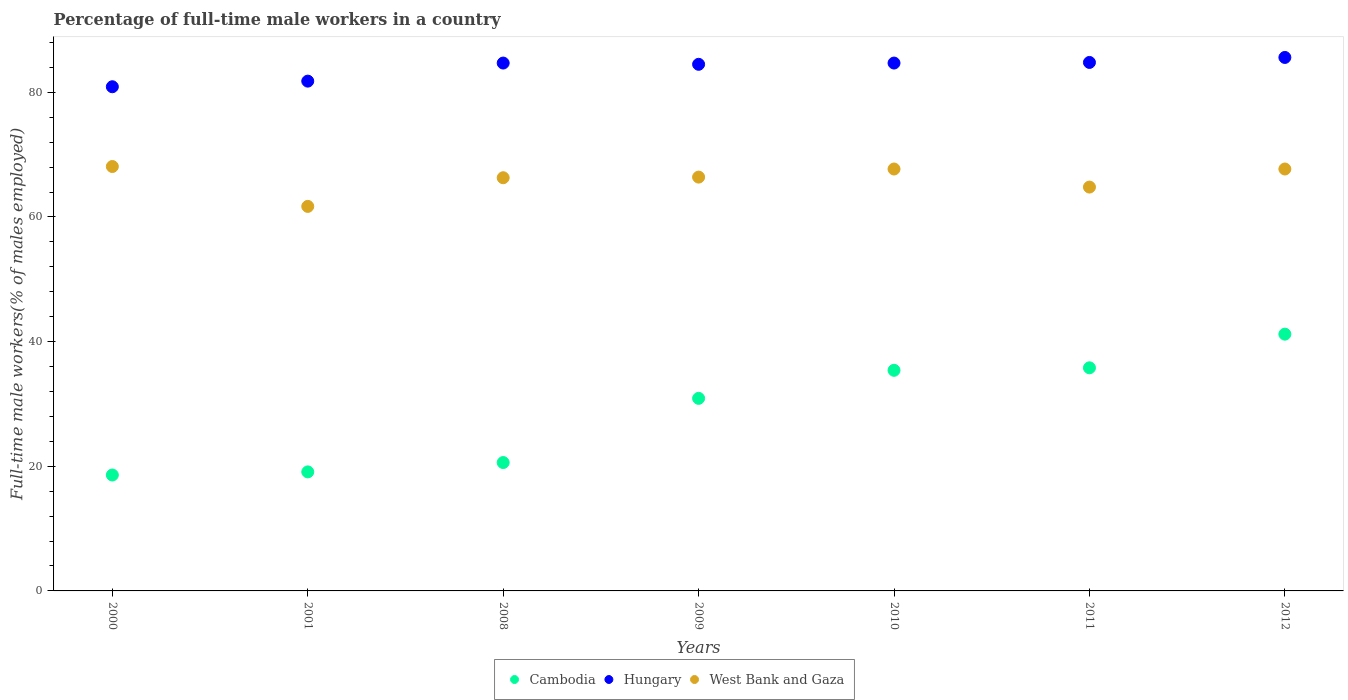Is the number of dotlines equal to the number of legend labels?
Offer a terse response. Yes. What is the percentage of full-time male workers in West Bank and Gaza in 2008?
Provide a succinct answer. 66.3. Across all years, what is the maximum percentage of full-time male workers in Hungary?
Make the answer very short. 85.6. Across all years, what is the minimum percentage of full-time male workers in West Bank and Gaza?
Ensure brevity in your answer.  61.7. In which year was the percentage of full-time male workers in West Bank and Gaza maximum?
Make the answer very short. 2000. What is the total percentage of full-time male workers in Cambodia in the graph?
Your response must be concise. 201.6. What is the difference between the percentage of full-time male workers in West Bank and Gaza in 2008 and that in 2010?
Provide a short and direct response. -1.4. What is the difference between the percentage of full-time male workers in West Bank and Gaza in 2000 and the percentage of full-time male workers in Cambodia in 2010?
Your response must be concise. 32.7. What is the average percentage of full-time male workers in Cambodia per year?
Give a very brief answer. 28.8. In the year 2000, what is the difference between the percentage of full-time male workers in Cambodia and percentage of full-time male workers in Hungary?
Your answer should be very brief. -62.3. What is the ratio of the percentage of full-time male workers in Hungary in 2001 to that in 2008?
Offer a very short reply. 0.97. Is the difference between the percentage of full-time male workers in Cambodia in 2000 and 2008 greater than the difference between the percentage of full-time male workers in Hungary in 2000 and 2008?
Offer a terse response. Yes. What is the difference between the highest and the second highest percentage of full-time male workers in West Bank and Gaza?
Your answer should be very brief. 0.4. What is the difference between the highest and the lowest percentage of full-time male workers in Cambodia?
Offer a very short reply. 22.6. Is it the case that in every year, the sum of the percentage of full-time male workers in Cambodia and percentage of full-time male workers in West Bank and Gaza  is greater than the percentage of full-time male workers in Hungary?
Provide a short and direct response. No. Does the percentage of full-time male workers in Cambodia monotonically increase over the years?
Provide a succinct answer. Yes. Is the percentage of full-time male workers in West Bank and Gaza strictly less than the percentage of full-time male workers in Cambodia over the years?
Offer a very short reply. No. Are the values on the major ticks of Y-axis written in scientific E-notation?
Provide a succinct answer. No. How are the legend labels stacked?
Give a very brief answer. Horizontal. What is the title of the graph?
Offer a very short reply. Percentage of full-time male workers in a country. What is the label or title of the X-axis?
Keep it short and to the point. Years. What is the label or title of the Y-axis?
Give a very brief answer. Full-time male workers(% of males employed). What is the Full-time male workers(% of males employed) of Cambodia in 2000?
Give a very brief answer. 18.6. What is the Full-time male workers(% of males employed) in Hungary in 2000?
Give a very brief answer. 80.9. What is the Full-time male workers(% of males employed) of West Bank and Gaza in 2000?
Your answer should be very brief. 68.1. What is the Full-time male workers(% of males employed) in Cambodia in 2001?
Give a very brief answer. 19.1. What is the Full-time male workers(% of males employed) of Hungary in 2001?
Provide a succinct answer. 81.8. What is the Full-time male workers(% of males employed) of West Bank and Gaza in 2001?
Make the answer very short. 61.7. What is the Full-time male workers(% of males employed) of Cambodia in 2008?
Ensure brevity in your answer.  20.6. What is the Full-time male workers(% of males employed) of Hungary in 2008?
Your answer should be very brief. 84.7. What is the Full-time male workers(% of males employed) in West Bank and Gaza in 2008?
Offer a terse response. 66.3. What is the Full-time male workers(% of males employed) in Cambodia in 2009?
Make the answer very short. 30.9. What is the Full-time male workers(% of males employed) of Hungary in 2009?
Keep it short and to the point. 84.5. What is the Full-time male workers(% of males employed) of West Bank and Gaza in 2009?
Give a very brief answer. 66.4. What is the Full-time male workers(% of males employed) in Cambodia in 2010?
Your answer should be very brief. 35.4. What is the Full-time male workers(% of males employed) of Hungary in 2010?
Keep it short and to the point. 84.7. What is the Full-time male workers(% of males employed) in West Bank and Gaza in 2010?
Your answer should be compact. 67.7. What is the Full-time male workers(% of males employed) in Cambodia in 2011?
Your response must be concise. 35.8. What is the Full-time male workers(% of males employed) of Hungary in 2011?
Provide a succinct answer. 84.8. What is the Full-time male workers(% of males employed) of West Bank and Gaza in 2011?
Your answer should be very brief. 64.8. What is the Full-time male workers(% of males employed) in Cambodia in 2012?
Ensure brevity in your answer.  41.2. What is the Full-time male workers(% of males employed) in Hungary in 2012?
Keep it short and to the point. 85.6. What is the Full-time male workers(% of males employed) of West Bank and Gaza in 2012?
Provide a succinct answer. 67.7. Across all years, what is the maximum Full-time male workers(% of males employed) of Cambodia?
Ensure brevity in your answer.  41.2. Across all years, what is the maximum Full-time male workers(% of males employed) in Hungary?
Ensure brevity in your answer.  85.6. Across all years, what is the maximum Full-time male workers(% of males employed) in West Bank and Gaza?
Offer a terse response. 68.1. Across all years, what is the minimum Full-time male workers(% of males employed) in Cambodia?
Make the answer very short. 18.6. Across all years, what is the minimum Full-time male workers(% of males employed) of Hungary?
Your response must be concise. 80.9. Across all years, what is the minimum Full-time male workers(% of males employed) of West Bank and Gaza?
Provide a short and direct response. 61.7. What is the total Full-time male workers(% of males employed) of Cambodia in the graph?
Provide a succinct answer. 201.6. What is the total Full-time male workers(% of males employed) in Hungary in the graph?
Make the answer very short. 587. What is the total Full-time male workers(% of males employed) in West Bank and Gaza in the graph?
Your answer should be compact. 462.7. What is the difference between the Full-time male workers(% of males employed) in Hungary in 2000 and that in 2001?
Provide a short and direct response. -0.9. What is the difference between the Full-time male workers(% of males employed) in Cambodia in 2000 and that in 2008?
Your answer should be compact. -2. What is the difference between the Full-time male workers(% of males employed) of Hungary in 2000 and that in 2008?
Make the answer very short. -3.8. What is the difference between the Full-time male workers(% of males employed) of West Bank and Gaza in 2000 and that in 2009?
Make the answer very short. 1.7. What is the difference between the Full-time male workers(% of males employed) of Cambodia in 2000 and that in 2010?
Make the answer very short. -16.8. What is the difference between the Full-time male workers(% of males employed) of Hungary in 2000 and that in 2010?
Give a very brief answer. -3.8. What is the difference between the Full-time male workers(% of males employed) in West Bank and Gaza in 2000 and that in 2010?
Ensure brevity in your answer.  0.4. What is the difference between the Full-time male workers(% of males employed) of Cambodia in 2000 and that in 2011?
Make the answer very short. -17.2. What is the difference between the Full-time male workers(% of males employed) of Hungary in 2000 and that in 2011?
Ensure brevity in your answer.  -3.9. What is the difference between the Full-time male workers(% of males employed) of Cambodia in 2000 and that in 2012?
Your response must be concise. -22.6. What is the difference between the Full-time male workers(% of males employed) of Hungary in 2000 and that in 2012?
Offer a very short reply. -4.7. What is the difference between the Full-time male workers(% of males employed) of Cambodia in 2001 and that in 2008?
Offer a terse response. -1.5. What is the difference between the Full-time male workers(% of males employed) of Hungary in 2001 and that in 2009?
Your response must be concise. -2.7. What is the difference between the Full-time male workers(% of males employed) in West Bank and Gaza in 2001 and that in 2009?
Your response must be concise. -4.7. What is the difference between the Full-time male workers(% of males employed) of Cambodia in 2001 and that in 2010?
Your answer should be compact. -16.3. What is the difference between the Full-time male workers(% of males employed) of West Bank and Gaza in 2001 and that in 2010?
Keep it short and to the point. -6. What is the difference between the Full-time male workers(% of males employed) in Cambodia in 2001 and that in 2011?
Offer a terse response. -16.7. What is the difference between the Full-time male workers(% of males employed) in Hungary in 2001 and that in 2011?
Give a very brief answer. -3. What is the difference between the Full-time male workers(% of males employed) in West Bank and Gaza in 2001 and that in 2011?
Keep it short and to the point. -3.1. What is the difference between the Full-time male workers(% of males employed) of Cambodia in 2001 and that in 2012?
Provide a succinct answer. -22.1. What is the difference between the Full-time male workers(% of males employed) of Cambodia in 2008 and that in 2010?
Give a very brief answer. -14.8. What is the difference between the Full-time male workers(% of males employed) of Hungary in 2008 and that in 2010?
Your response must be concise. 0. What is the difference between the Full-time male workers(% of males employed) in West Bank and Gaza in 2008 and that in 2010?
Keep it short and to the point. -1.4. What is the difference between the Full-time male workers(% of males employed) in Cambodia in 2008 and that in 2011?
Your answer should be compact. -15.2. What is the difference between the Full-time male workers(% of males employed) in Hungary in 2008 and that in 2011?
Offer a terse response. -0.1. What is the difference between the Full-time male workers(% of males employed) of Cambodia in 2008 and that in 2012?
Make the answer very short. -20.6. What is the difference between the Full-time male workers(% of males employed) in Hungary in 2008 and that in 2012?
Offer a terse response. -0.9. What is the difference between the Full-time male workers(% of males employed) of Cambodia in 2009 and that in 2010?
Give a very brief answer. -4.5. What is the difference between the Full-time male workers(% of males employed) in Hungary in 2009 and that in 2010?
Provide a succinct answer. -0.2. What is the difference between the Full-time male workers(% of males employed) of Hungary in 2009 and that in 2011?
Keep it short and to the point. -0.3. What is the difference between the Full-time male workers(% of males employed) of West Bank and Gaza in 2009 and that in 2011?
Give a very brief answer. 1.6. What is the difference between the Full-time male workers(% of males employed) in Cambodia in 2009 and that in 2012?
Offer a very short reply. -10.3. What is the difference between the Full-time male workers(% of males employed) of West Bank and Gaza in 2009 and that in 2012?
Your answer should be compact. -1.3. What is the difference between the Full-time male workers(% of males employed) in Cambodia in 2010 and that in 2011?
Your response must be concise. -0.4. What is the difference between the Full-time male workers(% of males employed) in Cambodia in 2011 and that in 2012?
Ensure brevity in your answer.  -5.4. What is the difference between the Full-time male workers(% of males employed) of Hungary in 2011 and that in 2012?
Ensure brevity in your answer.  -0.8. What is the difference between the Full-time male workers(% of males employed) in Cambodia in 2000 and the Full-time male workers(% of males employed) in Hungary in 2001?
Give a very brief answer. -63.2. What is the difference between the Full-time male workers(% of males employed) in Cambodia in 2000 and the Full-time male workers(% of males employed) in West Bank and Gaza in 2001?
Provide a succinct answer. -43.1. What is the difference between the Full-time male workers(% of males employed) of Hungary in 2000 and the Full-time male workers(% of males employed) of West Bank and Gaza in 2001?
Your answer should be very brief. 19.2. What is the difference between the Full-time male workers(% of males employed) of Cambodia in 2000 and the Full-time male workers(% of males employed) of Hungary in 2008?
Keep it short and to the point. -66.1. What is the difference between the Full-time male workers(% of males employed) of Cambodia in 2000 and the Full-time male workers(% of males employed) of West Bank and Gaza in 2008?
Your answer should be very brief. -47.7. What is the difference between the Full-time male workers(% of males employed) in Hungary in 2000 and the Full-time male workers(% of males employed) in West Bank and Gaza in 2008?
Offer a terse response. 14.6. What is the difference between the Full-time male workers(% of males employed) of Cambodia in 2000 and the Full-time male workers(% of males employed) of Hungary in 2009?
Provide a succinct answer. -65.9. What is the difference between the Full-time male workers(% of males employed) of Cambodia in 2000 and the Full-time male workers(% of males employed) of West Bank and Gaza in 2009?
Your answer should be compact. -47.8. What is the difference between the Full-time male workers(% of males employed) of Cambodia in 2000 and the Full-time male workers(% of males employed) of Hungary in 2010?
Make the answer very short. -66.1. What is the difference between the Full-time male workers(% of males employed) in Cambodia in 2000 and the Full-time male workers(% of males employed) in West Bank and Gaza in 2010?
Offer a very short reply. -49.1. What is the difference between the Full-time male workers(% of males employed) of Cambodia in 2000 and the Full-time male workers(% of males employed) of Hungary in 2011?
Offer a very short reply. -66.2. What is the difference between the Full-time male workers(% of males employed) of Cambodia in 2000 and the Full-time male workers(% of males employed) of West Bank and Gaza in 2011?
Give a very brief answer. -46.2. What is the difference between the Full-time male workers(% of males employed) of Cambodia in 2000 and the Full-time male workers(% of males employed) of Hungary in 2012?
Make the answer very short. -67. What is the difference between the Full-time male workers(% of males employed) of Cambodia in 2000 and the Full-time male workers(% of males employed) of West Bank and Gaza in 2012?
Ensure brevity in your answer.  -49.1. What is the difference between the Full-time male workers(% of males employed) of Cambodia in 2001 and the Full-time male workers(% of males employed) of Hungary in 2008?
Your answer should be very brief. -65.6. What is the difference between the Full-time male workers(% of males employed) in Cambodia in 2001 and the Full-time male workers(% of males employed) in West Bank and Gaza in 2008?
Ensure brevity in your answer.  -47.2. What is the difference between the Full-time male workers(% of males employed) in Hungary in 2001 and the Full-time male workers(% of males employed) in West Bank and Gaza in 2008?
Offer a terse response. 15.5. What is the difference between the Full-time male workers(% of males employed) of Cambodia in 2001 and the Full-time male workers(% of males employed) of Hungary in 2009?
Give a very brief answer. -65.4. What is the difference between the Full-time male workers(% of males employed) in Cambodia in 2001 and the Full-time male workers(% of males employed) in West Bank and Gaza in 2009?
Provide a succinct answer. -47.3. What is the difference between the Full-time male workers(% of males employed) of Cambodia in 2001 and the Full-time male workers(% of males employed) of Hungary in 2010?
Offer a terse response. -65.6. What is the difference between the Full-time male workers(% of males employed) of Cambodia in 2001 and the Full-time male workers(% of males employed) of West Bank and Gaza in 2010?
Your answer should be very brief. -48.6. What is the difference between the Full-time male workers(% of males employed) in Cambodia in 2001 and the Full-time male workers(% of males employed) in Hungary in 2011?
Your answer should be very brief. -65.7. What is the difference between the Full-time male workers(% of males employed) of Cambodia in 2001 and the Full-time male workers(% of males employed) of West Bank and Gaza in 2011?
Give a very brief answer. -45.7. What is the difference between the Full-time male workers(% of males employed) in Hungary in 2001 and the Full-time male workers(% of males employed) in West Bank and Gaza in 2011?
Provide a short and direct response. 17. What is the difference between the Full-time male workers(% of males employed) in Cambodia in 2001 and the Full-time male workers(% of males employed) in Hungary in 2012?
Make the answer very short. -66.5. What is the difference between the Full-time male workers(% of males employed) of Cambodia in 2001 and the Full-time male workers(% of males employed) of West Bank and Gaza in 2012?
Your answer should be very brief. -48.6. What is the difference between the Full-time male workers(% of males employed) in Hungary in 2001 and the Full-time male workers(% of males employed) in West Bank and Gaza in 2012?
Your answer should be very brief. 14.1. What is the difference between the Full-time male workers(% of males employed) of Cambodia in 2008 and the Full-time male workers(% of males employed) of Hungary in 2009?
Make the answer very short. -63.9. What is the difference between the Full-time male workers(% of males employed) of Cambodia in 2008 and the Full-time male workers(% of males employed) of West Bank and Gaza in 2009?
Provide a succinct answer. -45.8. What is the difference between the Full-time male workers(% of males employed) of Hungary in 2008 and the Full-time male workers(% of males employed) of West Bank and Gaza in 2009?
Keep it short and to the point. 18.3. What is the difference between the Full-time male workers(% of males employed) of Cambodia in 2008 and the Full-time male workers(% of males employed) of Hungary in 2010?
Your answer should be very brief. -64.1. What is the difference between the Full-time male workers(% of males employed) in Cambodia in 2008 and the Full-time male workers(% of males employed) in West Bank and Gaza in 2010?
Offer a terse response. -47.1. What is the difference between the Full-time male workers(% of males employed) in Cambodia in 2008 and the Full-time male workers(% of males employed) in Hungary in 2011?
Offer a very short reply. -64.2. What is the difference between the Full-time male workers(% of males employed) of Cambodia in 2008 and the Full-time male workers(% of males employed) of West Bank and Gaza in 2011?
Ensure brevity in your answer.  -44.2. What is the difference between the Full-time male workers(% of males employed) in Cambodia in 2008 and the Full-time male workers(% of males employed) in Hungary in 2012?
Keep it short and to the point. -65. What is the difference between the Full-time male workers(% of males employed) in Cambodia in 2008 and the Full-time male workers(% of males employed) in West Bank and Gaza in 2012?
Provide a short and direct response. -47.1. What is the difference between the Full-time male workers(% of males employed) of Cambodia in 2009 and the Full-time male workers(% of males employed) of Hungary in 2010?
Give a very brief answer. -53.8. What is the difference between the Full-time male workers(% of males employed) in Cambodia in 2009 and the Full-time male workers(% of males employed) in West Bank and Gaza in 2010?
Make the answer very short. -36.8. What is the difference between the Full-time male workers(% of males employed) of Cambodia in 2009 and the Full-time male workers(% of males employed) of Hungary in 2011?
Make the answer very short. -53.9. What is the difference between the Full-time male workers(% of males employed) of Cambodia in 2009 and the Full-time male workers(% of males employed) of West Bank and Gaza in 2011?
Your response must be concise. -33.9. What is the difference between the Full-time male workers(% of males employed) in Cambodia in 2009 and the Full-time male workers(% of males employed) in Hungary in 2012?
Your response must be concise. -54.7. What is the difference between the Full-time male workers(% of males employed) in Cambodia in 2009 and the Full-time male workers(% of males employed) in West Bank and Gaza in 2012?
Your answer should be very brief. -36.8. What is the difference between the Full-time male workers(% of males employed) in Hungary in 2009 and the Full-time male workers(% of males employed) in West Bank and Gaza in 2012?
Your response must be concise. 16.8. What is the difference between the Full-time male workers(% of males employed) in Cambodia in 2010 and the Full-time male workers(% of males employed) in Hungary in 2011?
Provide a succinct answer. -49.4. What is the difference between the Full-time male workers(% of males employed) of Cambodia in 2010 and the Full-time male workers(% of males employed) of West Bank and Gaza in 2011?
Provide a succinct answer. -29.4. What is the difference between the Full-time male workers(% of males employed) of Cambodia in 2010 and the Full-time male workers(% of males employed) of Hungary in 2012?
Make the answer very short. -50.2. What is the difference between the Full-time male workers(% of males employed) of Cambodia in 2010 and the Full-time male workers(% of males employed) of West Bank and Gaza in 2012?
Ensure brevity in your answer.  -32.3. What is the difference between the Full-time male workers(% of males employed) in Cambodia in 2011 and the Full-time male workers(% of males employed) in Hungary in 2012?
Give a very brief answer. -49.8. What is the difference between the Full-time male workers(% of males employed) in Cambodia in 2011 and the Full-time male workers(% of males employed) in West Bank and Gaza in 2012?
Provide a short and direct response. -31.9. What is the average Full-time male workers(% of males employed) in Cambodia per year?
Provide a short and direct response. 28.8. What is the average Full-time male workers(% of males employed) of Hungary per year?
Give a very brief answer. 83.86. What is the average Full-time male workers(% of males employed) in West Bank and Gaza per year?
Your answer should be compact. 66.1. In the year 2000, what is the difference between the Full-time male workers(% of males employed) in Cambodia and Full-time male workers(% of males employed) in Hungary?
Offer a terse response. -62.3. In the year 2000, what is the difference between the Full-time male workers(% of males employed) of Cambodia and Full-time male workers(% of males employed) of West Bank and Gaza?
Your answer should be very brief. -49.5. In the year 2000, what is the difference between the Full-time male workers(% of males employed) of Hungary and Full-time male workers(% of males employed) of West Bank and Gaza?
Provide a succinct answer. 12.8. In the year 2001, what is the difference between the Full-time male workers(% of males employed) in Cambodia and Full-time male workers(% of males employed) in Hungary?
Keep it short and to the point. -62.7. In the year 2001, what is the difference between the Full-time male workers(% of males employed) in Cambodia and Full-time male workers(% of males employed) in West Bank and Gaza?
Give a very brief answer. -42.6. In the year 2001, what is the difference between the Full-time male workers(% of males employed) in Hungary and Full-time male workers(% of males employed) in West Bank and Gaza?
Make the answer very short. 20.1. In the year 2008, what is the difference between the Full-time male workers(% of males employed) of Cambodia and Full-time male workers(% of males employed) of Hungary?
Keep it short and to the point. -64.1. In the year 2008, what is the difference between the Full-time male workers(% of males employed) in Cambodia and Full-time male workers(% of males employed) in West Bank and Gaza?
Offer a terse response. -45.7. In the year 2008, what is the difference between the Full-time male workers(% of males employed) of Hungary and Full-time male workers(% of males employed) of West Bank and Gaza?
Make the answer very short. 18.4. In the year 2009, what is the difference between the Full-time male workers(% of males employed) of Cambodia and Full-time male workers(% of males employed) of Hungary?
Provide a succinct answer. -53.6. In the year 2009, what is the difference between the Full-time male workers(% of males employed) of Cambodia and Full-time male workers(% of males employed) of West Bank and Gaza?
Provide a succinct answer. -35.5. In the year 2010, what is the difference between the Full-time male workers(% of males employed) in Cambodia and Full-time male workers(% of males employed) in Hungary?
Give a very brief answer. -49.3. In the year 2010, what is the difference between the Full-time male workers(% of males employed) of Cambodia and Full-time male workers(% of males employed) of West Bank and Gaza?
Your answer should be compact. -32.3. In the year 2011, what is the difference between the Full-time male workers(% of males employed) of Cambodia and Full-time male workers(% of males employed) of Hungary?
Make the answer very short. -49. In the year 2012, what is the difference between the Full-time male workers(% of males employed) of Cambodia and Full-time male workers(% of males employed) of Hungary?
Provide a succinct answer. -44.4. In the year 2012, what is the difference between the Full-time male workers(% of males employed) in Cambodia and Full-time male workers(% of males employed) in West Bank and Gaza?
Your response must be concise. -26.5. What is the ratio of the Full-time male workers(% of males employed) of Cambodia in 2000 to that in 2001?
Make the answer very short. 0.97. What is the ratio of the Full-time male workers(% of males employed) of Hungary in 2000 to that in 2001?
Give a very brief answer. 0.99. What is the ratio of the Full-time male workers(% of males employed) of West Bank and Gaza in 2000 to that in 2001?
Your answer should be very brief. 1.1. What is the ratio of the Full-time male workers(% of males employed) in Cambodia in 2000 to that in 2008?
Your answer should be very brief. 0.9. What is the ratio of the Full-time male workers(% of males employed) in Hungary in 2000 to that in 2008?
Provide a short and direct response. 0.96. What is the ratio of the Full-time male workers(% of males employed) in West Bank and Gaza in 2000 to that in 2008?
Provide a short and direct response. 1.03. What is the ratio of the Full-time male workers(% of males employed) in Cambodia in 2000 to that in 2009?
Give a very brief answer. 0.6. What is the ratio of the Full-time male workers(% of males employed) in Hungary in 2000 to that in 2009?
Your answer should be compact. 0.96. What is the ratio of the Full-time male workers(% of males employed) in West Bank and Gaza in 2000 to that in 2009?
Give a very brief answer. 1.03. What is the ratio of the Full-time male workers(% of males employed) in Cambodia in 2000 to that in 2010?
Give a very brief answer. 0.53. What is the ratio of the Full-time male workers(% of males employed) in Hungary in 2000 to that in 2010?
Provide a succinct answer. 0.96. What is the ratio of the Full-time male workers(% of males employed) in West Bank and Gaza in 2000 to that in 2010?
Provide a short and direct response. 1.01. What is the ratio of the Full-time male workers(% of males employed) in Cambodia in 2000 to that in 2011?
Keep it short and to the point. 0.52. What is the ratio of the Full-time male workers(% of males employed) in Hungary in 2000 to that in 2011?
Give a very brief answer. 0.95. What is the ratio of the Full-time male workers(% of males employed) of West Bank and Gaza in 2000 to that in 2011?
Offer a very short reply. 1.05. What is the ratio of the Full-time male workers(% of males employed) in Cambodia in 2000 to that in 2012?
Make the answer very short. 0.45. What is the ratio of the Full-time male workers(% of males employed) in Hungary in 2000 to that in 2012?
Offer a very short reply. 0.95. What is the ratio of the Full-time male workers(% of males employed) in West Bank and Gaza in 2000 to that in 2012?
Offer a very short reply. 1.01. What is the ratio of the Full-time male workers(% of males employed) of Cambodia in 2001 to that in 2008?
Provide a succinct answer. 0.93. What is the ratio of the Full-time male workers(% of males employed) of Hungary in 2001 to that in 2008?
Provide a succinct answer. 0.97. What is the ratio of the Full-time male workers(% of males employed) in West Bank and Gaza in 2001 to that in 2008?
Ensure brevity in your answer.  0.93. What is the ratio of the Full-time male workers(% of males employed) in Cambodia in 2001 to that in 2009?
Make the answer very short. 0.62. What is the ratio of the Full-time male workers(% of males employed) of Hungary in 2001 to that in 2009?
Provide a succinct answer. 0.97. What is the ratio of the Full-time male workers(% of males employed) of West Bank and Gaza in 2001 to that in 2009?
Provide a succinct answer. 0.93. What is the ratio of the Full-time male workers(% of males employed) in Cambodia in 2001 to that in 2010?
Keep it short and to the point. 0.54. What is the ratio of the Full-time male workers(% of males employed) in Hungary in 2001 to that in 2010?
Your answer should be compact. 0.97. What is the ratio of the Full-time male workers(% of males employed) in West Bank and Gaza in 2001 to that in 2010?
Your response must be concise. 0.91. What is the ratio of the Full-time male workers(% of males employed) of Cambodia in 2001 to that in 2011?
Make the answer very short. 0.53. What is the ratio of the Full-time male workers(% of males employed) in Hungary in 2001 to that in 2011?
Provide a short and direct response. 0.96. What is the ratio of the Full-time male workers(% of males employed) of West Bank and Gaza in 2001 to that in 2011?
Provide a succinct answer. 0.95. What is the ratio of the Full-time male workers(% of males employed) of Cambodia in 2001 to that in 2012?
Your response must be concise. 0.46. What is the ratio of the Full-time male workers(% of males employed) in Hungary in 2001 to that in 2012?
Offer a terse response. 0.96. What is the ratio of the Full-time male workers(% of males employed) in West Bank and Gaza in 2001 to that in 2012?
Offer a terse response. 0.91. What is the ratio of the Full-time male workers(% of males employed) in Hungary in 2008 to that in 2009?
Your answer should be compact. 1. What is the ratio of the Full-time male workers(% of males employed) of West Bank and Gaza in 2008 to that in 2009?
Your answer should be compact. 1. What is the ratio of the Full-time male workers(% of males employed) of Cambodia in 2008 to that in 2010?
Your response must be concise. 0.58. What is the ratio of the Full-time male workers(% of males employed) of West Bank and Gaza in 2008 to that in 2010?
Offer a terse response. 0.98. What is the ratio of the Full-time male workers(% of males employed) of Cambodia in 2008 to that in 2011?
Make the answer very short. 0.58. What is the ratio of the Full-time male workers(% of males employed) in Hungary in 2008 to that in 2011?
Your answer should be compact. 1. What is the ratio of the Full-time male workers(% of males employed) of West Bank and Gaza in 2008 to that in 2011?
Provide a short and direct response. 1.02. What is the ratio of the Full-time male workers(% of males employed) of West Bank and Gaza in 2008 to that in 2012?
Keep it short and to the point. 0.98. What is the ratio of the Full-time male workers(% of males employed) of Cambodia in 2009 to that in 2010?
Keep it short and to the point. 0.87. What is the ratio of the Full-time male workers(% of males employed) in Hungary in 2009 to that in 2010?
Your answer should be very brief. 1. What is the ratio of the Full-time male workers(% of males employed) of West Bank and Gaza in 2009 to that in 2010?
Give a very brief answer. 0.98. What is the ratio of the Full-time male workers(% of males employed) in Cambodia in 2009 to that in 2011?
Your answer should be very brief. 0.86. What is the ratio of the Full-time male workers(% of males employed) in Hungary in 2009 to that in 2011?
Your response must be concise. 1. What is the ratio of the Full-time male workers(% of males employed) of West Bank and Gaza in 2009 to that in 2011?
Ensure brevity in your answer.  1.02. What is the ratio of the Full-time male workers(% of males employed) in Hungary in 2009 to that in 2012?
Offer a terse response. 0.99. What is the ratio of the Full-time male workers(% of males employed) in West Bank and Gaza in 2009 to that in 2012?
Your response must be concise. 0.98. What is the ratio of the Full-time male workers(% of males employed) of Cambodia in 2010 to that in 2011?
Ensure brevity in your answer.  0.99. What is the ratio of the Full-time male workers(% of males employed) of West Bank and Gaza in 2010 to that in 2011?
Offer a very short reply. 1.04. What is the ratio of the Full-time male workers(% of males employed) in Cambodia in 2010 to that in 2012?
Provide a succinct answer. 0.86. What is the ratio of the Full-time male workers(% of males employed) in West Bank and Gaza in 2010 to that in 2012?
Give a very brief answer. 1. What is the ratio of the Full-time male workers(% of males employed) of Cambodia in 2011 to that in 2012?
Keep it short and to the point. 0.87. What is the ratio of the Full-time male workers(% of males employed) in Hungary in 2011 to that in 2012?
Offer a terse response. 0.99. What is the ratio of the Full-time male workers(% of males employed) of West Bank and Gaza in 2011 to that in 2012?
Provide a short and direct response. 0.96. What is the difference between the highest and the second highest Full-time male workers(% of males employed) in Hungary?
Provide a short and direct response. 0.8. What is the difference between the highest and the second highest Full-time male workers(% of males employed) of West Bank and Gaza?
Provide a succinct answer. 0.4. What is the difference between the highest and the lowest Full-time male workers(% of males employed) in Cambodia?
Make the answer very short. 22.6. 